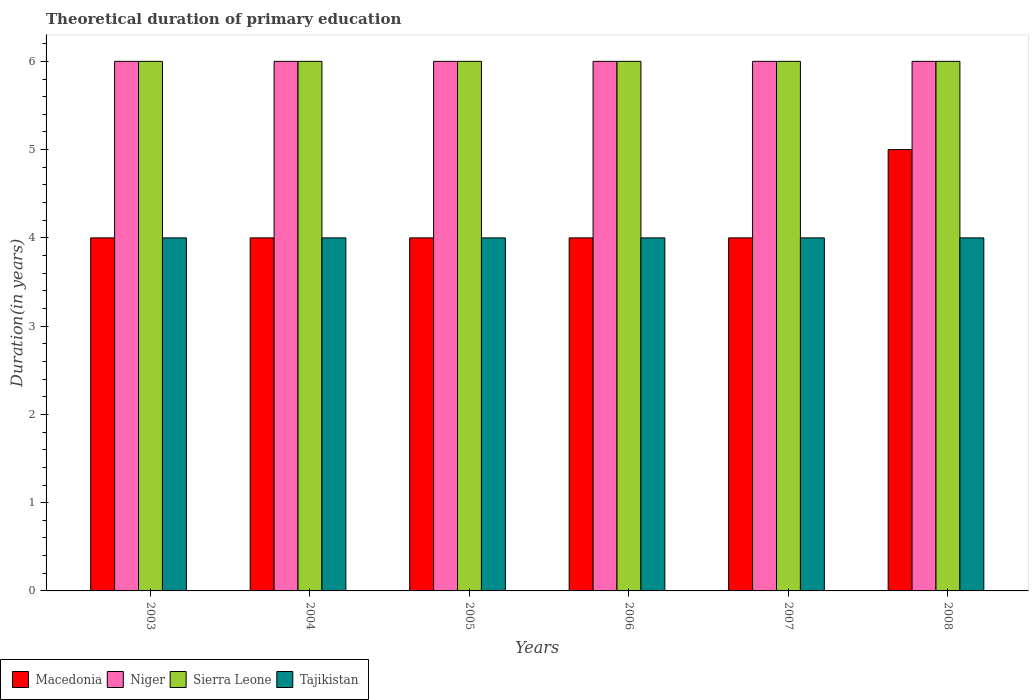How many groups of bars are there?
Your answer should be very brief. 6. Are the number of bars on each tick of the X-axis equal?
Offer a very short reply. Yes. In how many cases, is the number of bars for a given year not equal to the number of legend labels?
Provide a short and direct response. 0. Across all years, what is the maximum total theoretical duration of primary education in Sierra Leone?
Your answer should be compact. 6. In which year was the total theoretical duration of primary education in Tajikistan maximum?
Your answer should be very brief. 2003. What is the total total theoretical duration of primary education in Sierra Leone in the graph?
Ensure brevity in your answer.  36. What is the difference between the total theoretical duration of primary education in Macedonia in 2003 and that in 2008?
Your answer should be compact. -1. What is the difference between the total theoretical duration of primary education in Tajikistan in 2007 and the total theoretical duration of primary education in Niger in 2006?
Give a very brief answer. -2. In the year 2004, what is the difference between the total theoretical duration of primary education in Tajikistan and total theoretical duration of primary education in Sierra Leone?
Ensure brevity in your answer.  -2. What is the ratio of the total theoretical duration of primary education in Tajikistan in 2003 to that in 2007?
Ensure brevity in your answer.  1. Is the total theoretical duration of primary education in Niger in 2003 less than that in 2007?
Your answer should be compact. No. Is the difference between the total theoretical duration of primary education in Tajikistan in 2003 and 2007 greater than the difference between the total theoretical duration of primary education in Sierra Leone in 2003 and 2007?
Ensure brevity in your answer.  No. What is the difference between the highest and the second highest total theoretical duration of primary education in Sierra Leone?
Offer a very short reply. 0. What does the 3rd bar from the left in 2004 represents?
Provide a short and direct response. Sierra Leone. What does the 3rd bar from the right in 2003 represents?
Your answer should be compact. Niger. Is it the case that in every year, the sum of the total theoretical duration of primary education in Macedonia and total theoretical duration of primary education in Niger is greater than the total theoretical duration of primary education in Sierra Leone?
Keep it short and to the point. Yes. How many years are there in the graph?
Provide a succinct answer. 6. What is the difference between two consecutive major ticks on the Y-axis?
Provide a succinct answer. 1. Are the values on the major ticks of Y-axis written in scientific E-notation?
Make the answer very short. No. Does the graph contain any zero values?
Keep it short and to the point. No. Does the graph contain grids?
Offer a very short reply. No. Where does the legend appear in the graph?
Provide a succinct answer. Bottom left. How many legend labels are there?
Give a very brief answer. 4. How are the legend labels stacked?
Your answer should be very brief. Horizontal. What is the title of the graph?
Provide a succinct answer. Theoretical duration of primary education. Does "Grenada" appear as one of the legend labels in the graph?
Offer a very short reply. No. What is the label or title of the X-axis?
Your answer should be compact. Years. What is the label or title of the Y-axis?
Keep it short and to the point. Duration(in years). What is the Duration(in years) in Macedonia in 2004?
Your response must be concise. 4. What is the Duration(in years) in Niger in 2004?
Your response must be concise. 6. What is the Duration(in years) in Tajikistan in 2004?
Offer a very short reply. 4. What is the Duration(in years) in Tajikistan in 2005?
Your answer should be very brief. 4. What is the Duration(in years) in Macedonia in 2006?
Offer a very short reply. 4. What is the Duration(in years) of Niger in 2006?
Your answer should be compact. 6. What is the Duration(in years) in Macedonia in 2007?
Keep it short and to the point. 4. What is the Duration(in years) in Sierra Leone in 2007?
Your answer should be very brief. 6. What is the Duration(in years) of Macedonia in 2008?
Give a very brief answer. 5. What is the Duration(in years) in Niger in 2008?
Offer a very short reply. 6. What is the Duration(in years) in Tajikistan in 2008?
Provide a succinct answer. 4. Across all years, what is the maximum Duration(in years) of Sierra Leone?
Ensure brevity in your answer.  6. Across all years, what is the minimum Duration(in years) of Niger?
Make the answer very short. 6. What is the total Duration(in years) in Sierra Leone in the graph?
Make the answer very short. 36. What is the difference between the Duration(in years) in Niger in 2003 and that in 2004?
Make the answer very short. 0. What is the difference between the Duration(in years) in Macedonia in 2003 and that in 2005?
Your response must be concise. 0. What is the difference between the Duration(in years) in Sierra Leone in 2003 and that in 2005?
Your response must be concise. 0. What is the difference between the Duration(in years) of Tajikistan in 2003 and that in 2005?
Your answer should be very brief. 0. What is the difference between the Duration(in years) in Niger in 2003 and that in 2006?
Provide a succinct answer. 0. What is the difference between the Duration(in years) of Macedonia in 2003 and that in 2007?
Make the answer very short. 0. What is the difference between the Duration(in years) in Sierra Leone in 2003 and that in 2008?
Offer a very short reply. 0. What is the difference between the Duration(in years) of Macedonia in 2004 and that in 2006?
Give a very brief answer. 0. What is the difference between the Duration(in years) in Sierra Leone in 2004 and that in 2006?
Offer a terse response. 0. What is the difference between the Duration(in years) of Niger in 2004 and that in 2007?
Provide a short and direct response. 0. What is the difference between the Duration(in years) in Sierra Leone in 2004 and that in 2007?
Offer a very short reply. 0. What is the difference between the Duration(in years) in Tajikistan in 2004 and that in 2008?
Your response must be concise. 0. What is the difference between the Duration(in years) in Macedonia in 2005 and that in 2006?
Your answer should be very brief. 0. What is the difference between the Duration(in years) of Tajikistan in 2005 and that in 2006?
Ensure brevity in your answer.  0. What is the difference between the Duration(in years) in Sierra Leone in 2005 and that in 2007?
Provide a succinct answer. 0. What is the difference between the Duration(in years) of Tajikistan in 2005 and that in 2007?
Ensure brevity in your answer.  0. What is the difference between the Duration(in years) in Macedonia in 2005 and that in 2008?
Provide a succinct answer. -1. What is the difference between the Duration(in years) of Niger in 2005 and that in 2008?
Ensure brevity in your answer.  0. What is the difference between the Duration(in years) of Macedonia in 2006 and that in 2008?
Offer a very short reply. -1. What is the difference between the Duration(in years) of Niger in 2006 and that in 2008?
Offer a terse response. 0. What is the difference between the Duration(in years) of Macedonia in 2003 and the Duration(in years) of Sierra Leone in 2004?
Ensure brevity in your answer.  -2. What is the difference between the Duration(in years) of Macedonia in 2003 and the Duration(in years) of Tajikistan in 2004?
Your answer should be very brief. 0. What is the difference between the Duration(in years) of Niger in 2003 and the Duration(in years) of Sierra Leone in 2004?
Provide a short and direct response. 0. What is the difference between the Duration(in years) in Sierra Leone in 2003 and the Duration(in years) in Tajikistan in 2004?
Your answer should be compact. 2. What is the difference between the Duration(in years) of Niger in 2003 and the Duration(in years) of Sierra Leone in 2005?
Your response must be concise. 0. What is the difference between the Duration(in years) of Sierra Leone in 2003 and the Duration(in years) of Tajikistan in 2005?
Give a very brief answer. 2. What is the difference between the Duration(in years) in Macedonia in 2003 and the Duration(in years) in Tajikistan in 2006?
Keep it short and to the point. 0. What is the difference between the Duration(in years) in Niger in 2003 and the Duration(in years) in Sierra Leone in 2006?
Offer a very short reply. 0. What is the difference between the Duration(in years) in Sierra Leone in 2003 and the Duration(in years) in Tajikistan in 2006?
Provide a succinct answer. 2. What is the difference between the Duration(in years) in Macedonia in 2003 and the Duration(in years) in Tajikistan in 2007?
Provide a short and direct response. 0. What is the difference between the Duration(in years) in Niger in 2003 and the Duration(in years) in Sierra Leone in 2007?
Your answer should be compact. 0. What is the difference between the Duration(in years) of Sierra Leone in 2003 and the Duration(in years) of Tajikistan in 2007?
Ensure brevity in your answer.  2. What is the difference between the Duration(in years) in Niger in 2003 and the Duration(in years) in Tajikistan in 2008?
Offer a very short reply. 2. What is the difference between the Duration(in years) in Sierra Leone in 2003 and the Duration(in years) in Tajikistan in 2008?
Your answer should be compact. 2. What is the difference between the Duration(in years) in Macedonia in 2004 and the Duration(in years) in Niger in 2005?
Offer a very short reply. -2. What is the difference between the Duration(in years) of Macedonia in 2004 and the Duration(in years) of Tajikistan in 2005?
Offer a terse response. 0. What is the difference between the Duration(in years) in Sierra Leone in 2004 and the Duration(in years) in Tajikistan in 2006?
Make the answer very short. 2. What is the difference between the Duration(in years) of Macedonia in 2004 and the Duration(in years) of Niger in 2007?
Ensure brevity in your answer.  -2. What is the difference between the Duration(in years) of Macedonia in 2004 and the Duration(in years) of Tajikistan in 2007?
Offer a terse response. 0. What is the difference between the Duration(in years) of Niger in 2004 and the Duration(in years) of Sierra Leone in 2007?
Offer a terse response. 0. What is the difference between the Duration(in years) in Niger in 2004 and the Duration(in years) in Sierra Leone in 2008?
Give a very brief answer. 0. What is the difference between the Duration(in years) of Sierra Leone in 2004 and the Duration(in years) of Tajikistan in 2008?
Keep it short and to the point. 2. What is the difference between the Duration(in years) in Macedonia in 2005 and the Duration(in years) in Niger in 2006?
Ensure brevity in your answer.  -2. What is the difference between the Duration(in years) in Macedonia in 2005 and the Duration(in years) in Sierra Leone in 2006?
Offer a very short reply. -2. What is the difference between the Duration(in years) of Macedonia in 2005 and the Duration(in years) of Tajikistan in 2006?
Give a very brief answer. 0. What is the difference between the Duration(in years) of Niger in 2005 and the Duration(in years) of Sierra Leone in 2006?
Offer a terse response. 0. What is the difference between the Duration(in years) of Macedonia in 2005 and the Duration(in years) of Tajikistan in 2007?
Provide a short and direct response. 0. What is the difference between the Duration(in years) of Niger in 2005 and the Duration(in years) of Sierra Leone in 2007?
Provide a short and direct response. 0. What is the difference between the Duration(in years) in Niger in 2005 and the Duration(in years) in Tajikistan in 2007?
Make the answer very short. 2. What is the difference between the Duration(in years) of Sierra Leone in 2005 and the Duration(in years) of Tajikistan in 2007?
Ensure brevity in your answer.  2. What is the difference between the Duration(in years) of Macedonia in 2005 and the Duration(in years) of Niger in 2008?
Keep it short and to the point. -2. What is the difference between the Duration(in years) of Macedonia in 2005 and the Duration(in years) of Sierra Leone in 2008?
Offer a very short reply. -2. What is the difference between the Duration(in years) of Sierra Leone in 2005 and the Duration(in years) of Tajikistan in 2008?
Provide a short and direct response. 2. What is the difference between the Duration(in years) of Macedonia in 2006 and the Duration(in years) of Sierra Leone in 2007?
Make the answer very short. -2. What is the difference between the Duration(in years) in Macedonia in 2006 and the Duration(in years) in Tajikistan in 2007?
Your answer should be very brief. 0. What is the difference between the Duration(in years) of Sierra Leone in 2006 and the Duration(in years) of Tajikistan in 2007?
Your answer should be compact. 2. What is the difference between the Duration(in years) of Niger in 2006 and the Duration(in years) of Tajikistan in 2008?
Provide a succinct answer. 2. What is the difference between the Duration(in years) in Sierra Leone in 2006 and the Duration(in years) in Tajikistan in 2008?
Your response must be concise. 2. What is the difference between the Duration(in years) of Niger in 2007 and the Duration(in years) of Sierra Leone in 2008?
Give a very brief answer. 0. What is the difference between the Duration(in years) of Niger in 2007 and the Duration(in years) of Tajikistan in 2008?
Provide a short and direct response. 2. What is the difference between the Duration(in years) of Sierra Leone in 2007 and the Duration(in years) of Tajikistan in 2008?
Your answer should be compact. 2. What is the average Duration(in years) of Macedonia per year?
Make the answer very short. 4.17. What is the average Duration(in years) in Niger per year?
Your response must be concise. 6. What is the average Duration(in years) of Sierra Leone per year?
Offer a terse response. 6. What is the average Duration(in years) of Tajikistan per year?
Make the answer very short. 4. In the year 2003, what is the difference between the Duration(in years) of Niger and Duration(in years) of Sierra Leone?
Your response must be concise. 0. In the year 2003, what is the difference between the Duration(in years) of Sierra Leone and Duration(in years) of Tajikistan?
Give a very brief answer. 2. In the year 2004, what is the difference between the Duration(in years) of Macedonia and Duration(in years) of Niger?
Ensure brevity in your answer.  -2. In the year 2004, what is the difference between the Duration(in years) of Niger and Duration(in years) of Sierra Leone?
Your response must be concise. 0. In the year 2005, what is the difference between the Duration(in years) of Macedonia and Duration(in years) of Sierra Leone?
Give a very brief answer. -2. In the year 2005, what is the difference between the Duration(in years) of Macedonia and Duration(in years) of Tajikistan?
Your answer should be very brief. 0. In the year 2005, what is the difference between the Duration(in years) in Niger and Duration(in years) in Sierra Leone?
Ensure brevity in your answer.  0. In the year 2006, what is the difference between the Duration(in years) in Macedonia and Duration(in years) in Sierra Leone?
Your answer should be very brief. -2. In the year 2006, what is the difference between the Duration(in years) in Macedonia and Duration(in years) in Tajikistan?
Offer a very short reply. 0. In the year 2007, what is the difference between the Duration(in years) in Macedonia and Duration(in years) in Sierra Leone?
Ensure brevity in your answer.  -2. In the year 2007, what is the difference between the Duration(in years) of Macedonia and Duration(in years) of Tajikistan?
Your answer should be compact. 0. In the year 2007, what is the difference between the Duration(in years) of Niger and Duration(in years) of Sierra Leone?
Keep it short and to the point. 0. In the year 2008, what is the difference between the Duration(in years) of Macedonia and Duration(in years) of Niger?
Offer a terse response. -1. In the year 2008, what is the difference between the Duration(in years) of Niger and Duration(in years) of Sierra Leone?
Your answer should be compact. 0. In the year 2008, what is the difference between the Duration(in years) in Niger and Duration(in years) in Tajikistan?
Offer a terse response. 2. In the year 2008, what is the difference between the Duration(in years) in Sierra Leone and Duration(in years) in Tajikistan?
Give a very brief answer. 2. What is the ratio of the Duration(in years) of Macedonia in 2003 to that in 2004?
Your answer should be very brief. 1. What is the ratio of the Duration(in years) in Sierra Leone in 2003 to that in 2004?
Provide a short and direct response. 1. What is the ratio of the Duration(in years) of Tajikistan in 2003 to that in 2004?
Provide a succinct answer. 1. What is the ratio of the Duration(in years) of Macedonia in 2003 to that in 2005?
Provide a short and direct response. 1. What is the ratio of the Duration(in years) of Sierra Leone in 2003 to that in 2005?
Provide a short and direct response. 1. What is the ratio of the Duration(in years) in Tajikistan in 2003 to that in 2005?
Give a very brief answer. 1. What is the ratio of the Duration(in years) of Niger in 2003 to that in 2006?
Your response must be concise. 1. What is the ratio of the Duration(in years) of Macedonia in 2003 to that in 2007?
Provide a succinct answer. 1. What is the ratio of the Duration(in years) of Sierra Leone in 2003 to that in 2007?
Provide a short and direct response. 1. What is the ratio of the Duration(in years) in Macedonia in 2003 to that in 2008?
Offer a terse response. 0.8. What is the ratio of the Duration(in years) in Sierra Leone in 2003 to that in 2008?
Your answer should be very brief. 1. What is the ratio of the Duration(in years) in Niger in 2004 to that in 2005?
Your answer should be compact. 1. What is the ratio of the Duration(in years) in Sierra Leone in 2004 to that in 2005?
Your answer should be compact. 1. What is the ratio of the Duration(in years) of Tajikistan in 2004 to that in 2006?
Your answer should be compact. 1. What is the ratio of the Duration(in years) in Niger in 2004 to that in 2007?
Your answer should be very brief. 1. What is the ratio of the Duration(in years) in Sierra Leone in 2004 to that in 2008?
Your answer should be compact. 1. What is the ratio of the Duration(in years) of Tajikistan in 2004 to that in 2008?
Ensure brevity in your answer.  1. What is the ratio of the Duration(in years) in Tajikistan in 2005 to that in 2006?
Offer a terse response. 1. What is the ratio of the Duration(in years) of Niger in 2005 to that in 2008?
Offer a very short reply. 1. What is the ratio of the Duration(in years) of Sierra Leone in 2005 to that in 2008?
Keep it short and to the point. 1. What is the ratio of the Duration(in years) of Sierra Leone in 2006 to that in 2008?
Give a very brief answer. 1. What is the ratio of the Duration(in years) in Tajikistan in 2007 to that in 2008?
Keep it short and to the point. 1. What is the difference between the highest and the lowest Duration(in years) of Macedonia?
Keep it short and to the point. 1. 